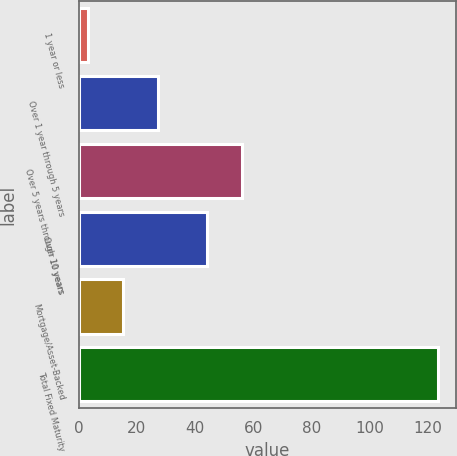<chart> <loc_0><loc_0><loc_500><loc_500><bar_chart><fcel>1 year or less<fcel>Over 1 year through 5 years<fcel>Over 5 years through 10 years<fcel>Over 10 years<fcel>Mortgage/Asset-Backed<fcel>Total Fixed Maturity<nl><fcel>3.1<fcel>27.18<fcel>56.04<fcel>44<fcel>15.14<fcel>123.5<nl></chart> 